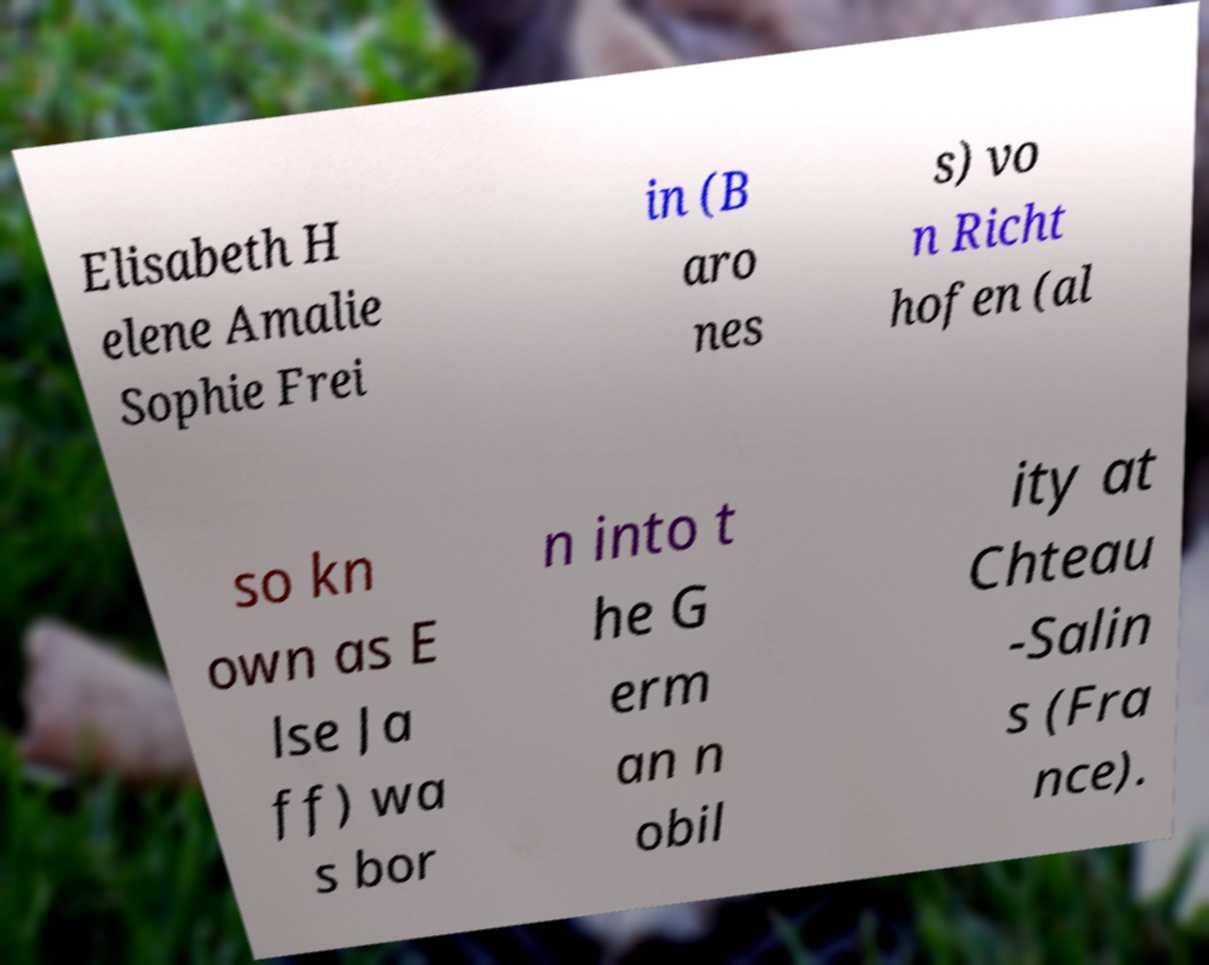For documentation purposes, I need the text within this image transcribed. Could you provide that? Elisabeth H elene Amalie Sophie Frei in (B aro nes s) vo n Richt hofen (al so kn own as E lse Ja ff) wa s bor n into t he G erm an n obil ity at Chteau -Salin s (Fra nce). 